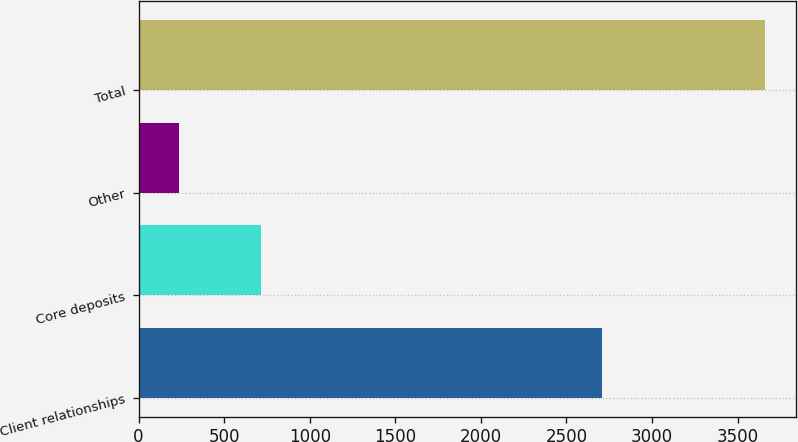Convert chart to OTSL. <chart><loc_0><loc_0><loc_500><loc_500><bar_chart><fcel>Client relationships<fcel>Core deposits<fcel>Other<fcel>Total<nl><fcel>2706<fcel>717<fcel>234<fcel>3657<nl></chart> 